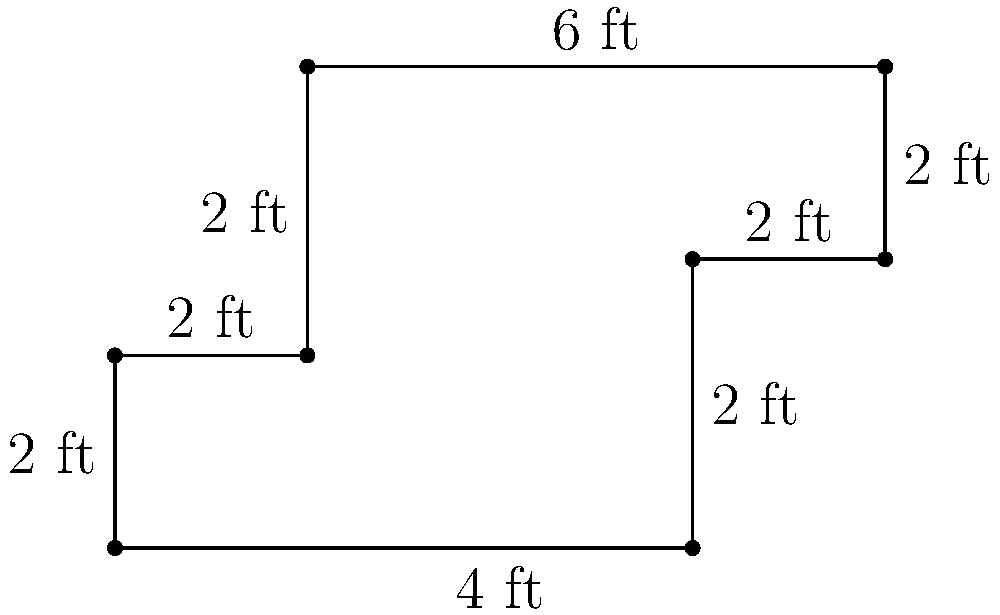As a night owl copywriter, you've decided to upgrade your workspace with a custom-built, irregularly shaped writing desk. The desk's unique design is shown in the diagram above, with measurements in feet. Calculate the total surface area of the desk top to determine how much writing space you'll have for your late-night creative sessions. To calculate the area of this irregularly shaped desk, we'll break it down into rectangles and add their areas:

1. Main rectangle:
   Length = 6 ft, Width = 2 ft
   Area = $6 \times 2 = 12$ sq ft

2. Left extension:
   Length = 2 ft, Width = 3 ft
   Area = $2 \times 3 = 6$ sq ft

3. Right extension:
   Length = 2 ft, Width = 2 ft
   Area = $2 \times 2 = 4$ sq ft

4. Top right extension:
   Length = 2 ft, Width = 2 ft
   Area = $2 \times 2 = 4$ sq ft

Total area:
$$\text{Total Area} = 12 + 6 + 4 + 4 = 26 \text{ sq ft}$$

Therefore, the total surface area of the writing desk is 26 square feet.
Answer: 26 sq ft 